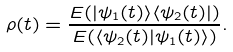<formula> <loc_0><loc_0><loc_500><loc_500>\rho ( t ) = \frac { E ( | \psi _ { 1 } ( t ) \rangle \langle \psi _ { 2 } ( t ) | ) } { E ( \langle \psi _ { 2 } ( t ) | \psi _ { 1 } ( t ) \rangle ) } .</formula> 